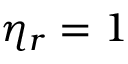Convert formula to latex. <formula><loc_0><loc_0><loc_500><loc_500>\eta _ { r } = 1</formula> 